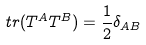Convert formula to latex. <formula><loc_0><loc_0><loc_500><loc_500>t r ( T ^ { A } T ^ { B } ) = \frac { 1 } { 2 } \delta _ { A B }</formula> 